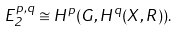<formula> <loc_0><loc_0><loc_500><loc_500>E _ { 2 } ^ { p , q } \cong H ^ { p } ( G , H ^ { q } ( X , R ) ) .</formula> 